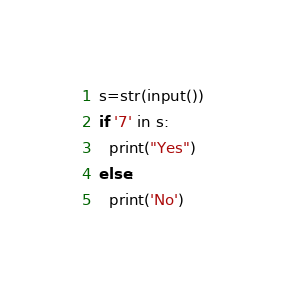Convert code to text. <code><loc_0><loc_0><loc_500><loc_500><_Python_>s=str(input())
if '7' in s:
  print("Yes")
else:
  print('No')</code> 